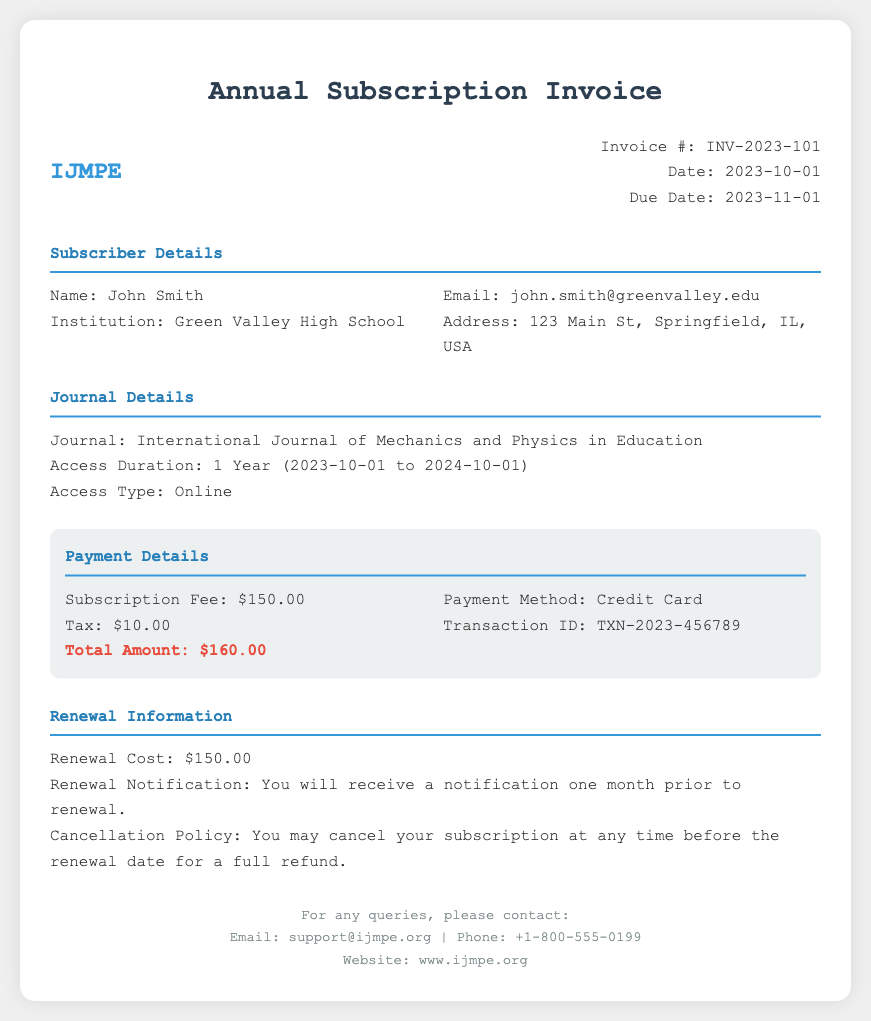What is the invoice number? The invoice number is listed in the document under invoice details, which is INV-2023-101.
Answer: INV-2023-101 Who is the subscriber? The name of the subscriber is displayed in the subscriber details section as John Smith.
Answer: John Smith What is the subscription fee? The subscription fee is specifically mentioned in the payment details section as $150.00.
Answer: $150.00 What is the access duration for the journal? The access duration is indicated in the journal details as 1 Year (2023-10-01 to 2024-10-01).
Answer: 1 Year (2023-10-01 to 2024-10-01) When is the due date for payment? The due date is provided in the invoice details section as 2023-11-01.
Answer: 2023-11-01 What will the renewal notification be? The renewal notification is described as you will receive a notification one month prior to renewal.
Answer: One month prior to renewal What is the cancellation policy? The cancellation policy states that you may cancel your subscription at any time before the renewal date for a full refund.
Answer: Full refund before the renewal date What is the total amount due? The total amount is specified in the payment details as $160.00.
Answer: $160.00 What payment method was used? The payment method is mentioned in the payment details as Credit Card.
Answer: Credit Card 